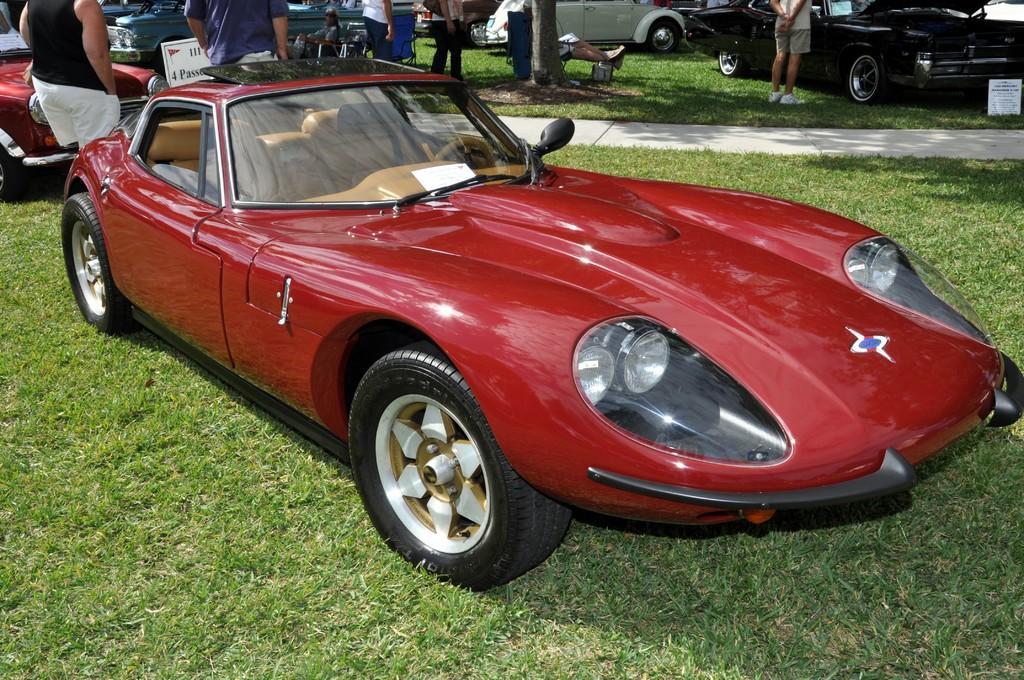How would you summarize this image in a sentence or two? In this picture we can see a red car on the grass ground. In the background, we can see many people and vehicles on the grass. 